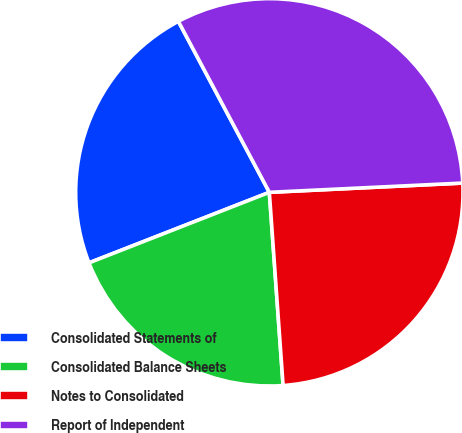Convert chart to OTSL. <chart><loc_0><loc_0><loc_500><loc_500><pie_chart><fcel>Consolidated Statements of<fcel>Consolidated Balance Sheets<fcel>Notes to Consolidated<fcel>Report of Independent<nl><fcel>23.15%<fcel>20.2%<fcel>24.63%<fcel>32.02%<nl></chart> 